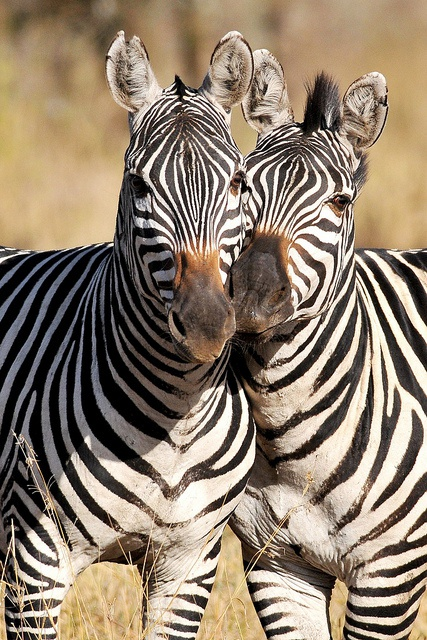Describe the objects in this image and their specific colors. I can see zebra in gray, black, ivory, and darkgray tones and zebra in gray, ivory, and black tones in this image. 